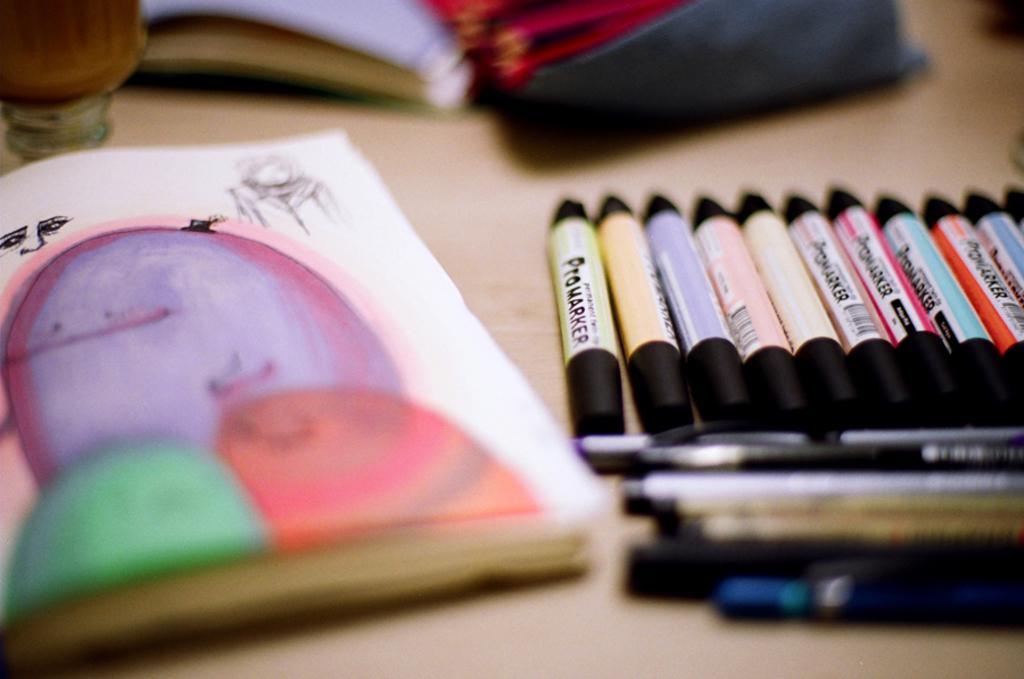Could you give a brief overview of what you see in this image? In this picture we can see crayons, pens, books and some objects and these all are placed on a platform. 